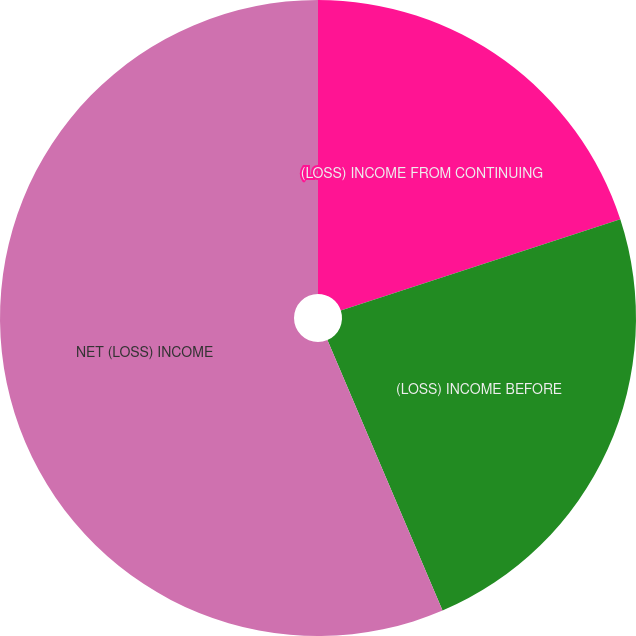<chart> <loc_0><loc_0><loc_500><loc_500><pie_chart><fcel>(LOSS) INCOME FROM CONTINUING<fcel>(LOSS) INCOME BEFORE<fcel>NET (LOSS) INCOME<nl><fcel>19.98%<fcel>23.62%<fcel>56.41%<nl></chart> 